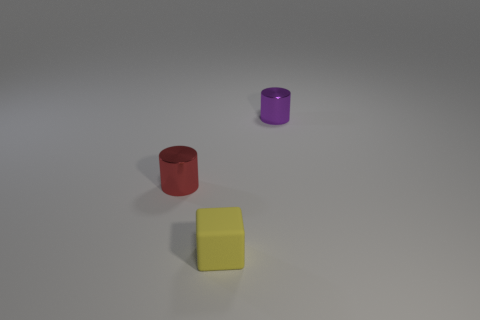What number of other things are made of the same material as the red cylinder?
Keep it short and to the point. 1. There is a object that is behind the yellow matte cube and in front of the small purple shiny thing; what is its size?
Provide a short and direct response. Small. There is a small metal object in front of the small metal object on the right side of the yellow cube; what is its shape?
Offer a very short reply. Cylinder. Is there anything else that is the same shape as the small yellow matte thing?
Offer a terse response. No. Are there the same number of red cylinders on the right side of the small purple cylinder and purple cylinders?
Give a very brief answer. No. Is the color of the tiny rubber cube the same as the tiny metal cylinder left of the small purple metal cylinder?
Offer a terse response. No. There is a tiny object that is in front of the purple metal cylinder and right of the red thing; what color is it?
Your response must be concise. Yellow. What number of small shiny objects are to the right of the tiny cylinder that is to the left of the small purple object?
Ensure brevity in your answer.  1. Is there a blue metallic thing of the same shape as the purple shiny thing?
Your answer should be compact. No. Is the shape of the object that is behind the red shiny cylinder the same as the metallic thing to the left of the small block?
Ensure brevity in your answer.  Yes. 